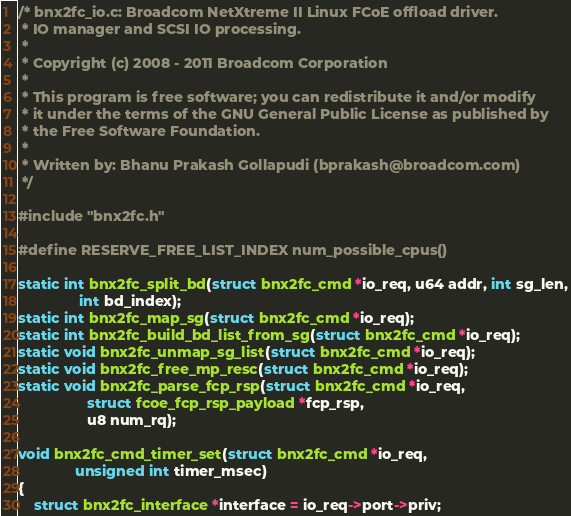<code> <loc_0><loc_0><loc_500><loc_500><_C_>/* bnx2fc_io.c: Broadcom NetXtreme II Linux FCoE offload driver.
 * IO manager and SCSI IO processing.
 *
 * Copyright (c) 2008 - 2011 Broadcom Corporation
 *
 * This program is free software; you can redistribute it and/or modify
 * it under the terms of the GNU General Public License as published by
 * the Free Software Foundation.
 *
 * Written by: Bhanu Prakash Gollapudi (bprakash@broadcom.com)
 */

#include "bnx2fc.h"

#define RESERVE_FREE_LIST_INDEX num_possible_cpus()

static int bnx2fc_split_bd(struct bnx2fc_cmd *io_req, u64 addr, int sg_len,
			   int bd_index);
static int bnx2fc_map_sg(struct bnx2fc_cmd *io_req);
static int bnx2fc_build_bd_list_from_sg(struct bnx2fc_cmd *io_req);
static void bnx2fc_unmap_sg_list(struct bnx2fc_cmd *io_req);
static void bnx2fc_free_mp_resc(struct bnx2fc_cmd *io_req);
static void bnx2fc_parse_fcp_rsp(struct bnx2fc_cmd *io_req,
				 struct fcoe_fcp_rsp_payload *fcp_rsp,
				 u8 num_rq);

void bnx2fc_cmd_timer_set(struct bnx2fc_cmd *io_req,
			  unsigned int timer_msec)
{
	struct bnx2fc_interface *interface = io_req->port->priv;
</code> 